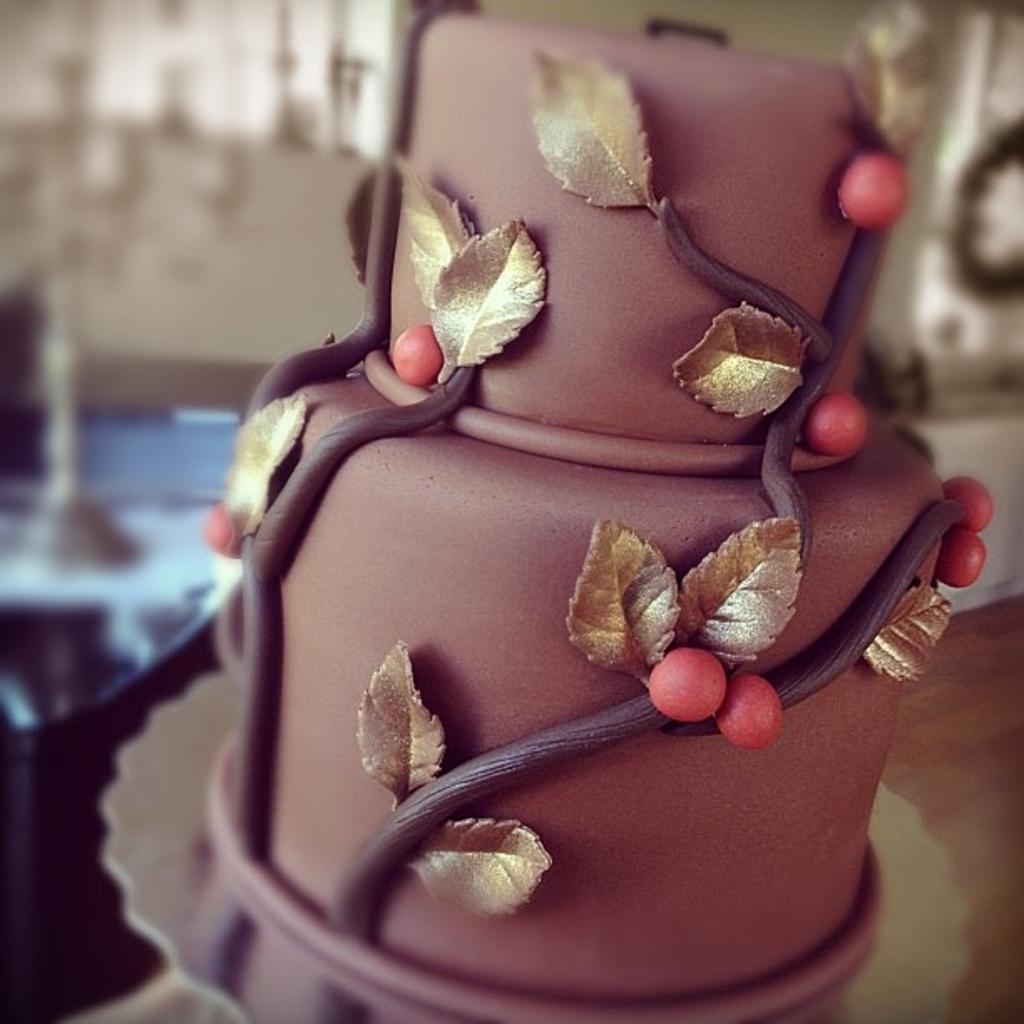What is the main subject of the image? There is a cake on a plate in the image. Can you describe the background of the image? The background of the image is blurred. How many times did the person pull the shock cord in the image? There is no shock cord or any indication of pulling in the image; it only features a cake on a plate with a blurred background. 